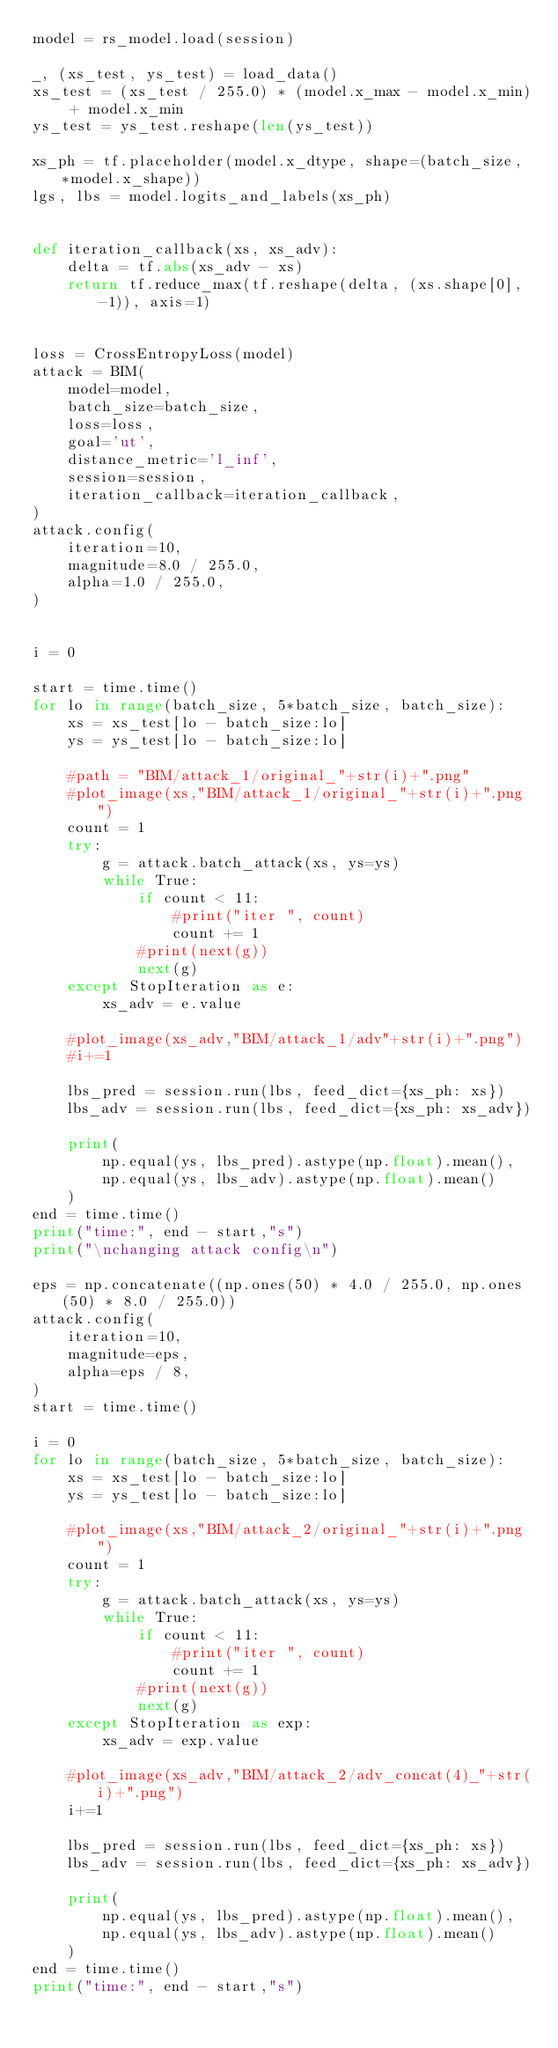Convert code to text. <code><loc_0><loc_0><loc_500><loc_500><_Python_>model = rs_model.load(session)

_, (xs_test, ys_test) = load_data()
xs_test = (xs_test / 255.0) * (model.x_max - model.x_min) + model.x_min
ys_test = ys_test.reshape(len(ys_test))

xs_ph = tf.placeholder(model.x_dtype, shape=(batch_size, *model.x_shape))
lgs, lbs = model.logits_and_labels(xs_ph)


def iteration_callback(xs, xs_adv):
    delta = tf.abs(xs_adv - xs)
    return tf.reduce_max(tf.reshape(delta, (xs.shape[0], -1)), axis=1)


loss = CrossEntropyLoss(model)
attack = BIM(
    model=model,
    batch_size=batch_size,
    loss=loss,
    goal='ut',
    distance_metric='l_inf',
    session=session,
    iteration_callback=iteration_callback,
)
attack.config(
    iteration=10,
    magnitude=8.0 / 255.0,
    alpha=1.0 / 255.0,
)


i = 0

start = time.time()
for lo in range(batch_size, 5*batch_size, batch_size):
    xs = xs_test[lo - batch_size:lo]
    ys = ys_test[lo - batch_size:lo]

    #path = "BIM/attack_1/original_"+str(i)+".png"
    #plot_image(xs,"BIM/attack_1/original_"+str(i)+".png")
    count = 1
    try:
        g = attack.batch_attack(xs, ys=ys)
        while True:
            if count < 11:
                #print("iter ", count)
                count += 1
            #print(next(g))
            next(g)
    except StopIteration as e:
        xs_adv = e.value

    #plot_image(xs_adv,"BIM/attack_1/adv"+str(i)+".png")
    #i+=1

    lbs_pred = session.run(lbs, feed_dict={xs_ph: xs})
    lbs_adv = session.run(lbs, feed_dict={xs_ph: xs_adv})

    print(
        np.equal(ys, lbs_pred).astype(np.float).mean(),
        np.equal(ys, lbs_adv).astype(np.float).mean()
    )
end = time.time()
print("time:", end - start,"s")
print("\nchanging attack config\n")

eps = np.concatenate((np.ones(50) * 4.0 / 255.0, np.ones(50) * 8.0 / 255.0))
attack.config(
    iteration=10,
    magnitude=eps,
    alpha=eps / 8,
)
start = time.time()

i = 0
for lo in range(batch_size, 5*batch_size, batch_size):
    xs = xs_test[lo - batch_size:lo]
    ys = ys_test[lo - batch_size:lo]
    
    #plot_image(xs,"BIM/attack_2/original_"+str(i)+".png")
    count = 1
    try:
        g = attack.batch_attack(xs, ys=ys)
        while True:
            if count < 11:
                #print("iter ", count)
                count += 1
            #print(next(g))
            next(g)
    except StopIteration as exp:
        xs_adv = exp.value

    #plot_image(xs_adv,"BIM/attack_2/adv_concat(4)_"+str(i)+".png")
    i+=1

    lbs_pred = session.run(lbs, feed_dict={xs_ph: xs})
    lbs_adv = session.run(lbs, feed_dict={xs_ph: xs_adv})

    print(
        np.equal(ys, lbs_pred).astype(np.float).mean(),
        np.equal(ys, lbs_adv).astype(np.float).mean()
    )
end = time.time()
print("time:", end - start,"s")
</code> 